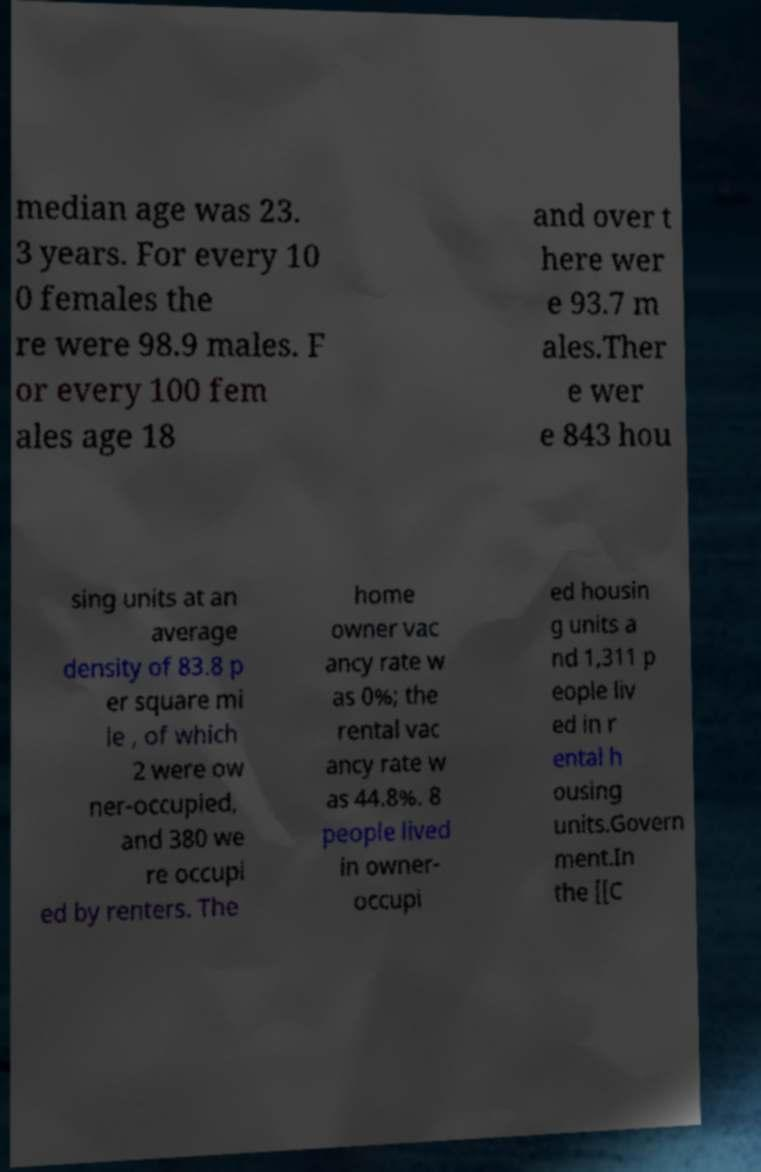For documentation purposes, I need the text within this image transcribed. Could you provide that? median age was 23. 3 years. For every 10 0 females the re were 98.9 males. F or every 100 fem ales age 18 and over t here wer e 93.7 m ales.Ther e wer e 843 hou sing units at an average density of 83.8 p er square mi le , of which 2 were ow ner-occupied, and 380 we re occupi ed by renters. The home owner vac ancy rate w as 0%; the rental vac ancy rate w as 44.8%. 8 people lived in owner- occupi ed housin g units a nd 1,311 p eople liv ed in r ental h ousing units.Govern ment.In the [[C 